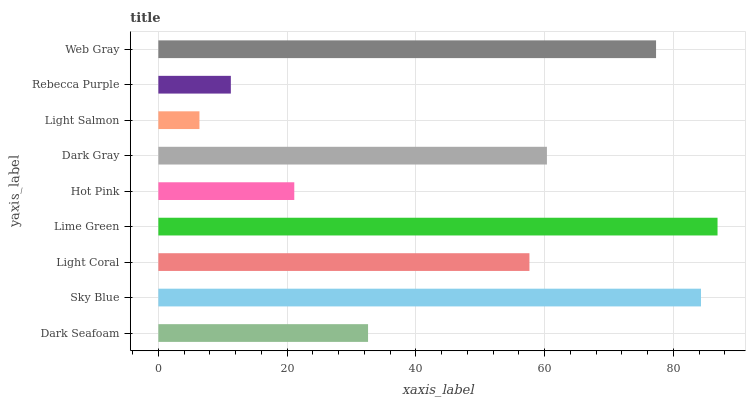Is Light Salmon the minimum?
Answer yes or no. Yes. Is Lime Green the maximum?
Answer yes or no. Yes. Is Sky Blue the minimum?
Answer yes or no. No. Is Sky Blue the maximum?
Answer yes or no. No. Is Sky Blue greater than Dark Seafoam?
Answer yes or no. Yes. Is Dark Seafoam less than Sky Blue?
Answer yes or no. Yes. Is Dark Seafoam greater than Sky Blue?
Answer yes or no. No. Is Sky Blue less than Dark Seafoam?
Answer yes or no. No. Is Light Coral the high median?
Answer yes or no. Yes. Is Light Coral the low median?
Answer yes or no. Yes. Is Rebecca Purple the high median?
Answer yes or no. No. Is Lime Green the low median?
Answer yes or no. No. 